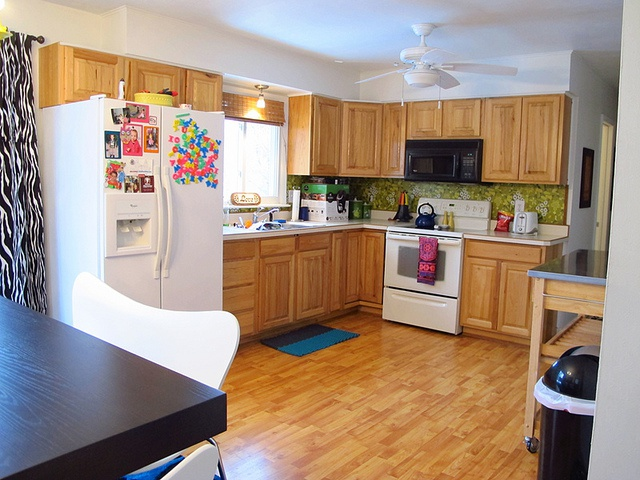Describe the objects in this image and their specific colors. I can see refrigerator in white, lightgray, and darkgray tones, dining table in white, gray, and black tones, chair in white, darkgray, lightgray, and black tones, oven in white, tan, darkgray, lightgray, and gray tones, and microwave in white, black, and gray tones in this image. 